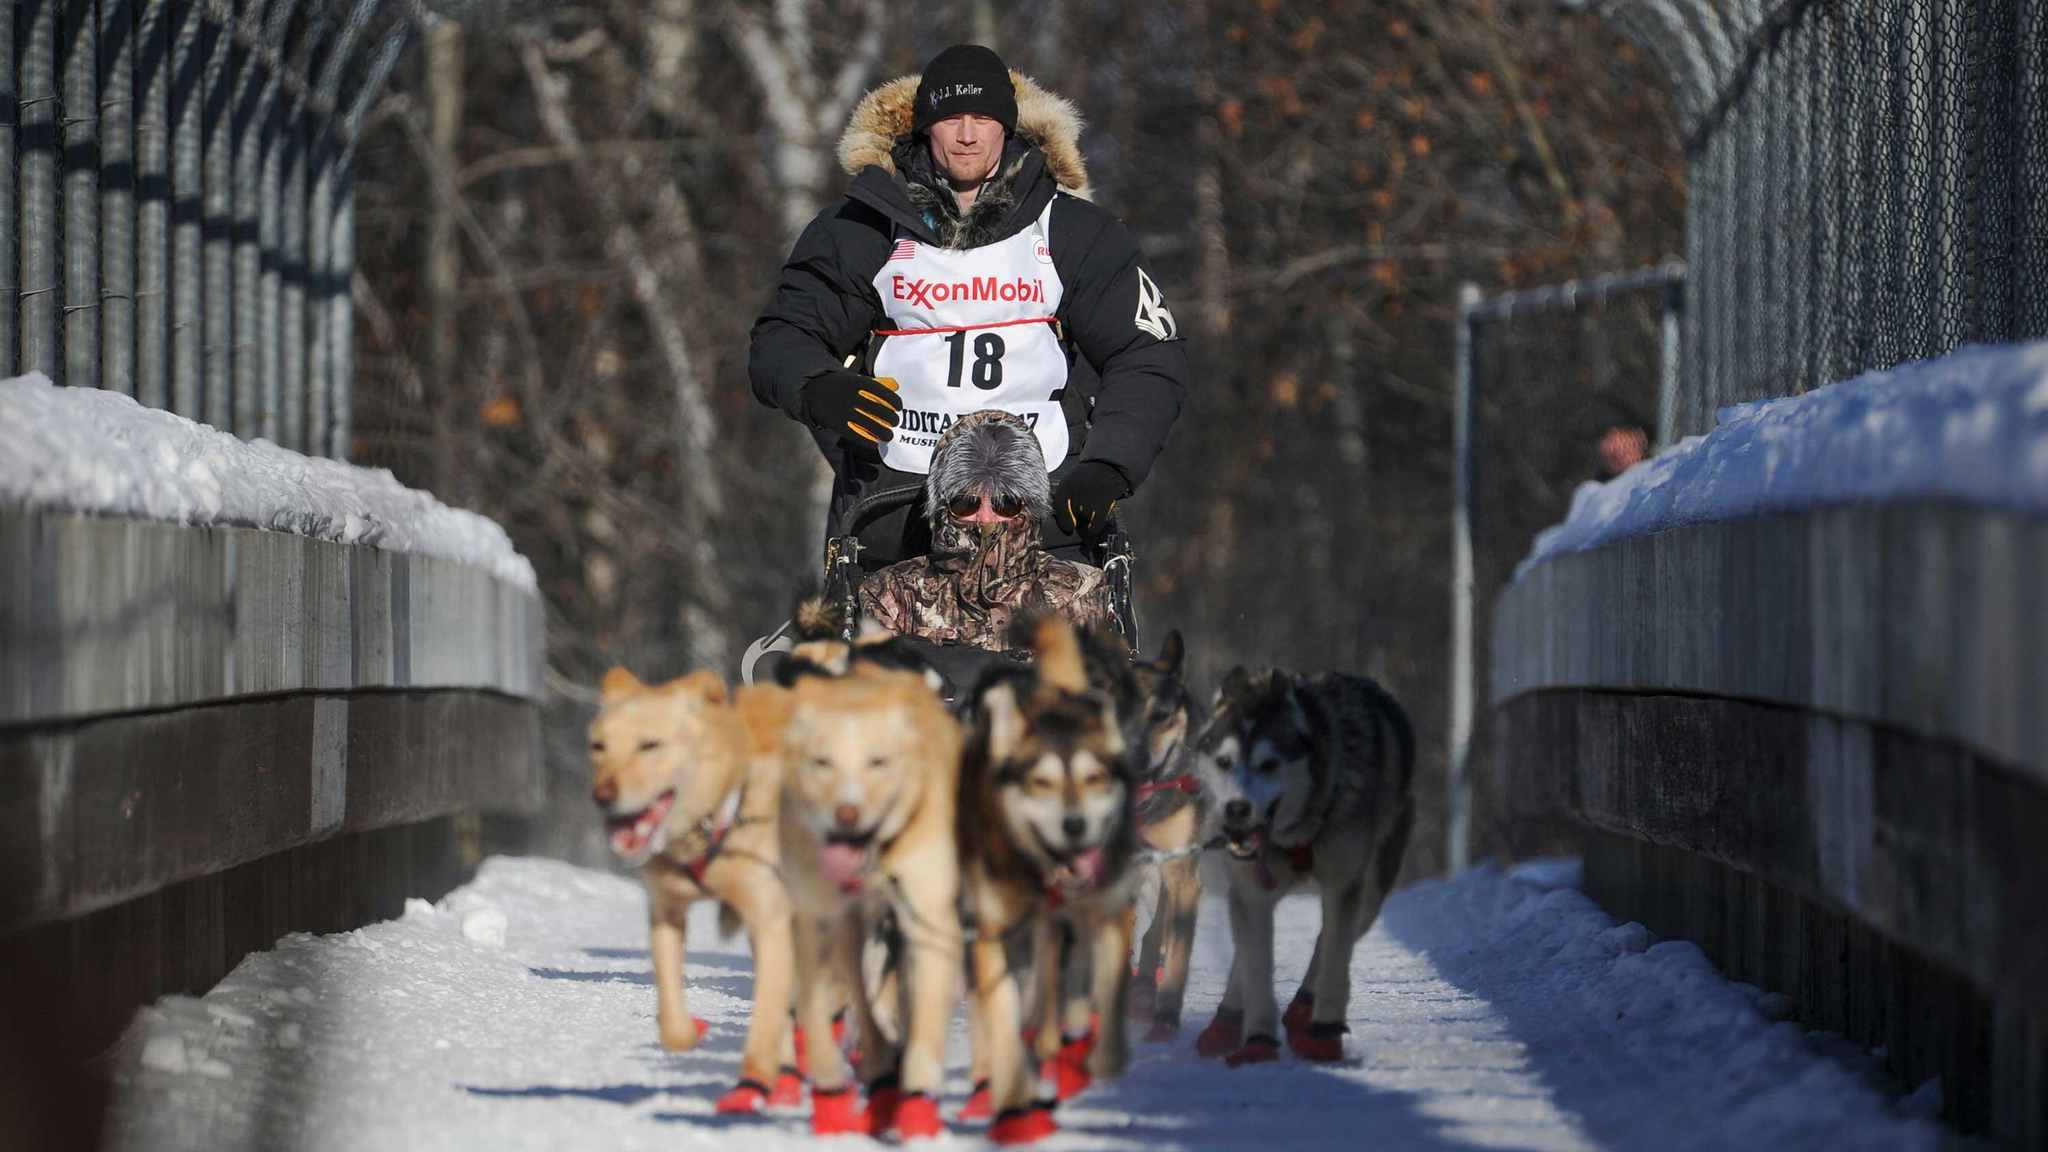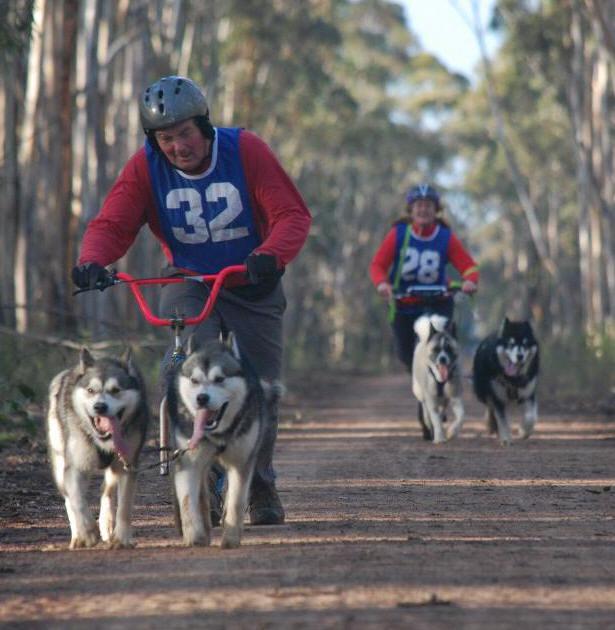The first image is the image on the left, the second image is the image on the right. Analyze the images presented: Is the assertion "The sled rider in the image on the left is wearing a white vest with a number." valid? Answer yes or no. Yes. The first image is the image on the left, the second image is the image on the right. Examine the images to the left and right. Is the description "Right image shows a team of dogs moving over snowy ground toward the camera." accurate? Answer yes or no. No. 